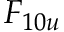Convert formula to latex. <formula><loc_0><loc_0><loc_500><loc_500>F _ { 1 0 u }</formula> 